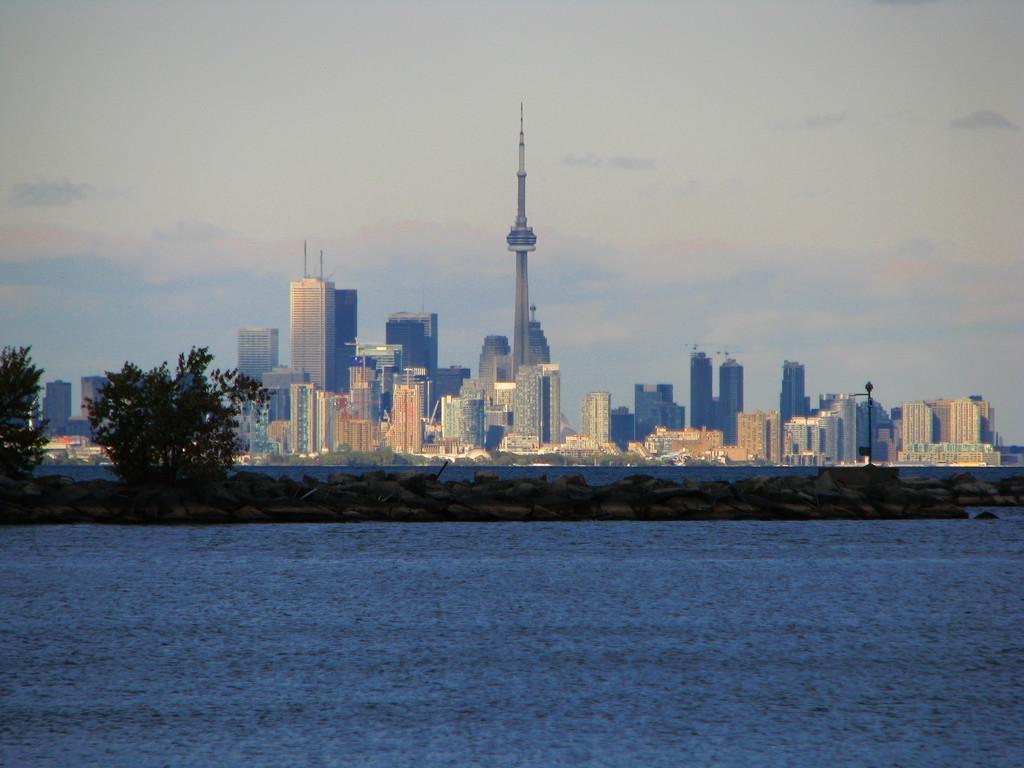Can you describe this image briefly? In this image at the bottom there is a river, and in the center there are some trees and grass. And in the background there are buildings and skyscrapers. At the top there is sky. 